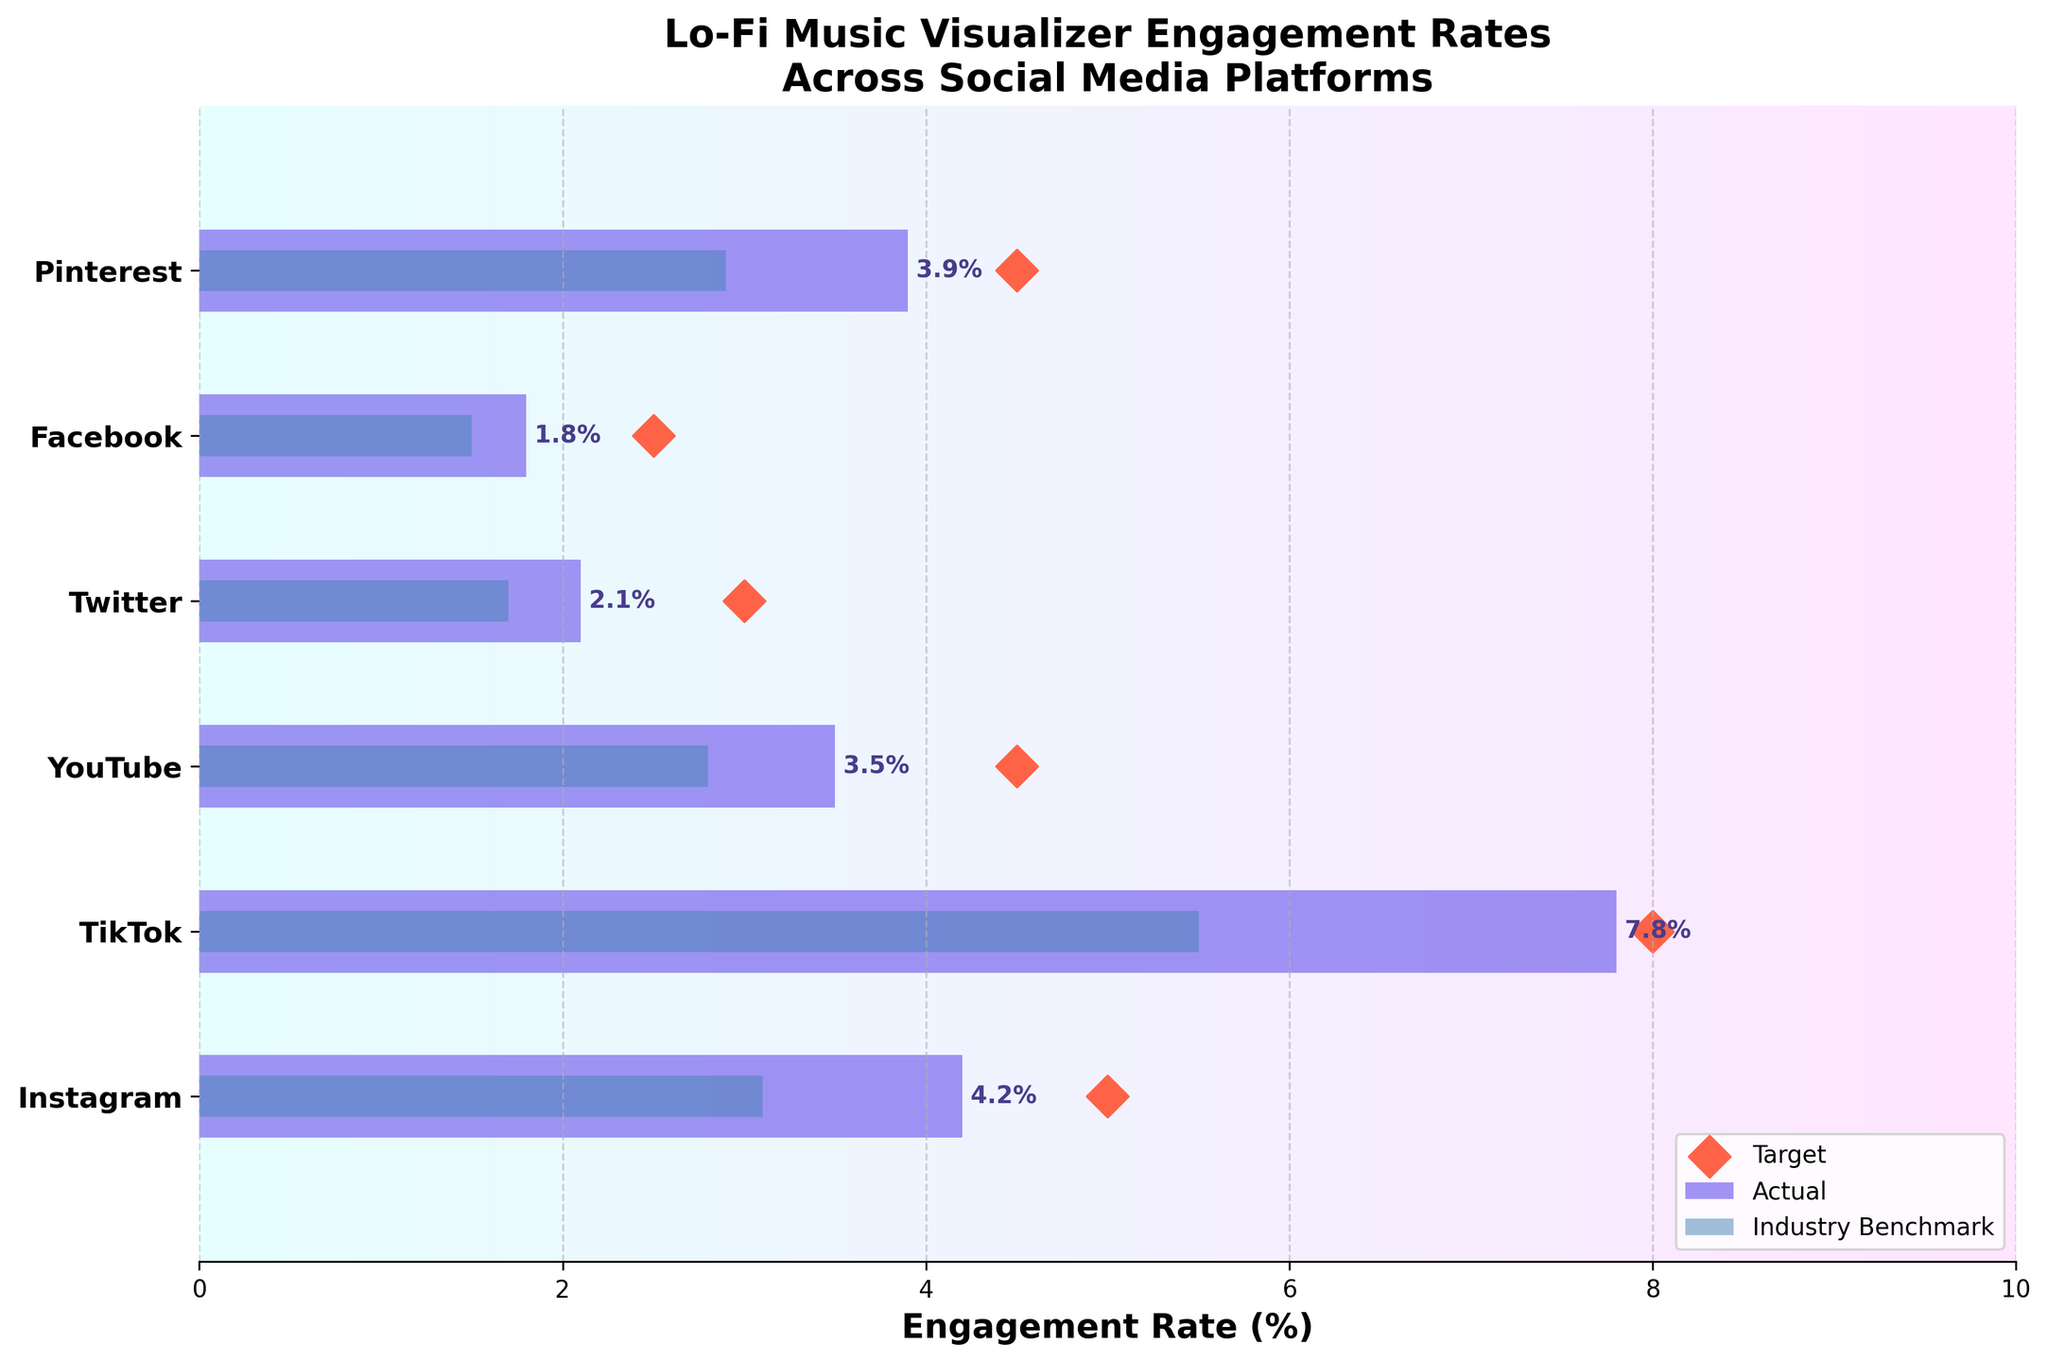what is the title of the plot? The title of the plot is located at the top of the figure. It is written in bold and larger font size than the rest of the text.
Answer: "Lo-Fi Music Visualizer Engagement Rates Across Social Media Platforms" How many social media platforms are analyzed in the figure? Count the number of y-axis labels representing different categories. Each label corresponds to a social media platform.
Answer: 6 Which platform has the highest actual engagement rate? Compare the lengths of the actual engagement rate bars for each platform. The longest bar represents the highest engagement rate.
Answer: TikTok How does Instagram's actual engagement rate compare to its industry benchmark? Look at the lengths of the bars for Instagram related to actual engagement rate and industry benchmark. Compare their values.
Answer: Instagram's actual engagement rate (4.2%) is higher than its industry benchmark (3.1%) What is the target engagement rate for YouTube? The target engagement rate is represented by the diamond marker for each platform. Look for the marker on the YouTube line.
Answer: 4.5% Does TikTok exceed its target engagement rate? Compare TikTok's actual engagement rate (length of the bar) to its target engagement rate (location of the marker).
Answer: No, TikTok's actual engagement rate (7.8%) is slightly below its target (8.0%) What is the difference between Pinterest's actual engagement rate and its target? Subtract Pinterest's actual engagement rate (3.9%) from its target engagement rate (4.5%).
Answer: 0.6% Which platform's engagement rate is closest to its target? Find the absolute difference between actual and target engagement rates for each platform and identify the smallest difference.
Answer: TikTok (0.2) Rank the platforms from highest to lowest based on their industry benchmark engagement rates. Order the platforms based on the comparative bar heights or values provided for each platform.
Answer: TikTok, Instagram, Pinterest, YouTube, Twitter, Facebook Are there any platforms where neither the actual engagement rate nor the industry benchmark reach the target? Check for each platform if both the actual engagement rate and industry benchmark are below the target marker.
Answer: Yes, Twitter and Facebook 